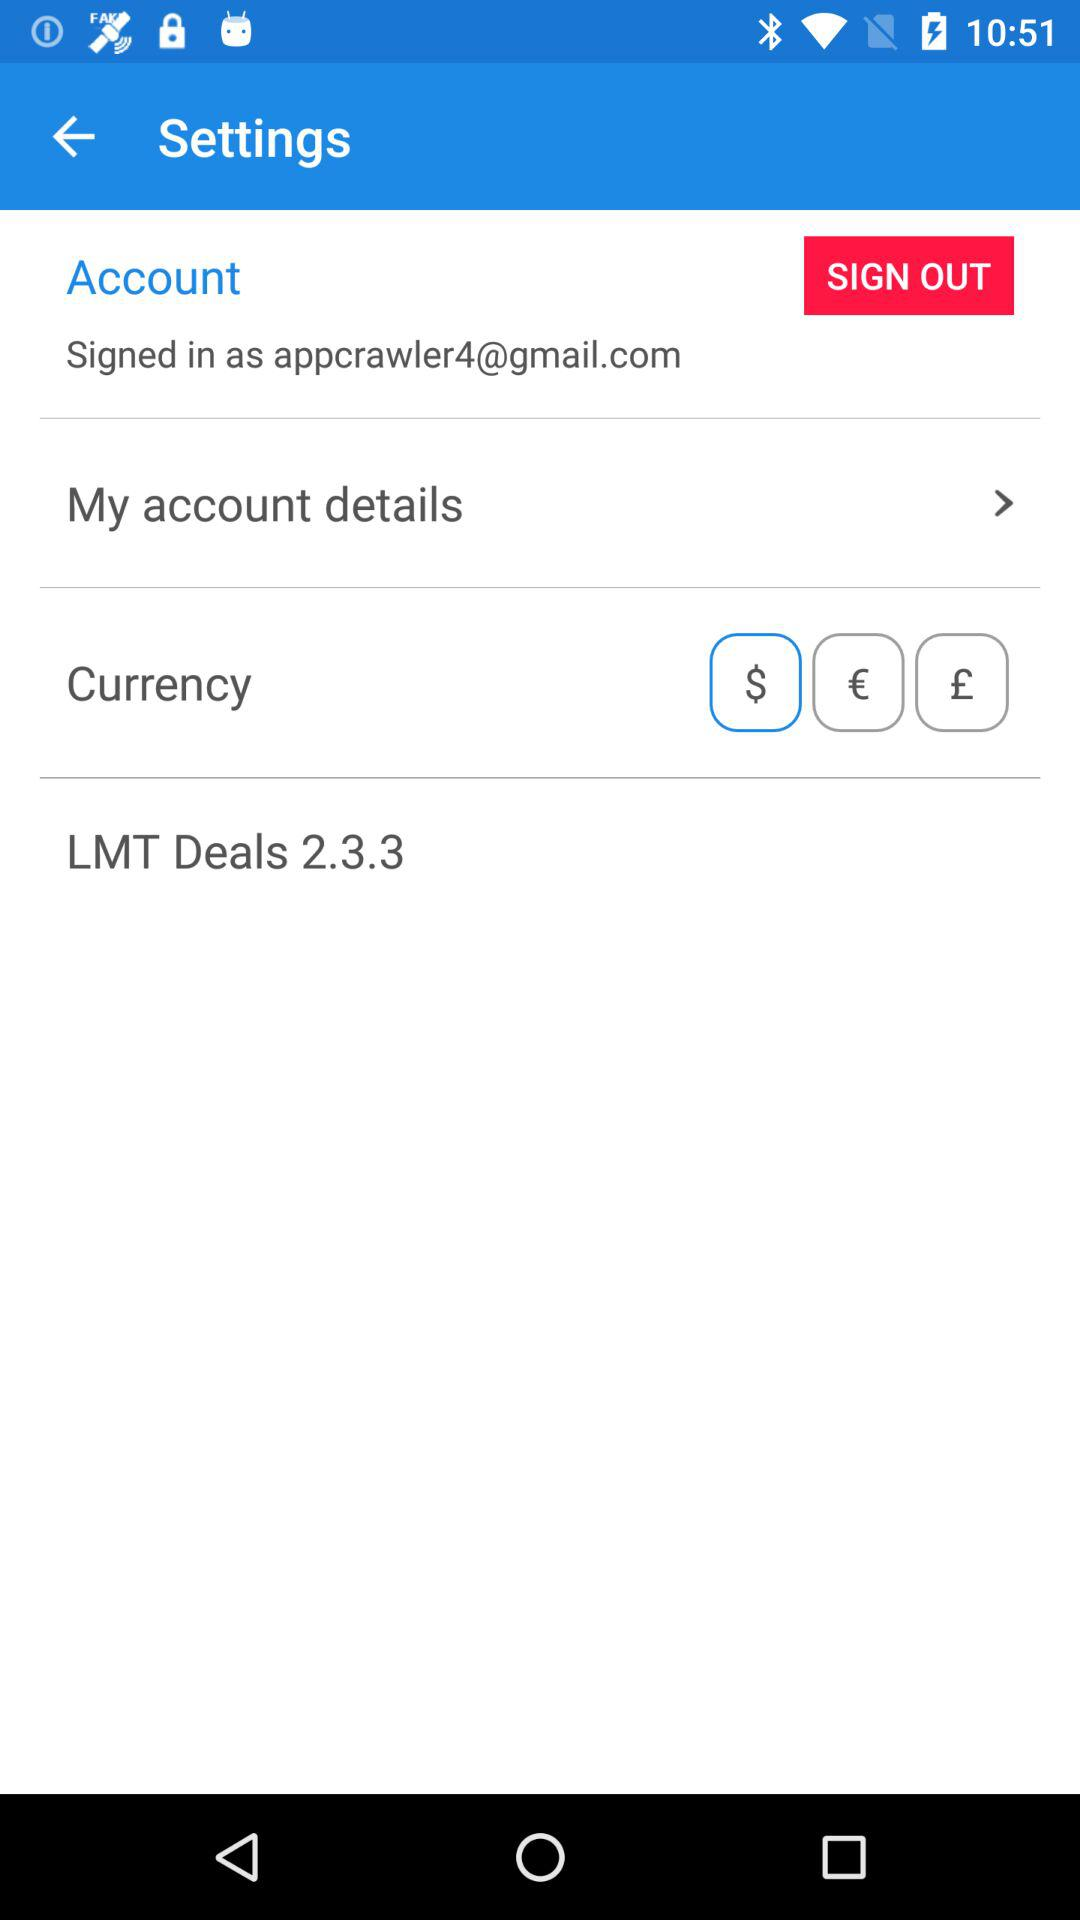How many currencies are available?
Answer the question using a single word or phrase. 3 